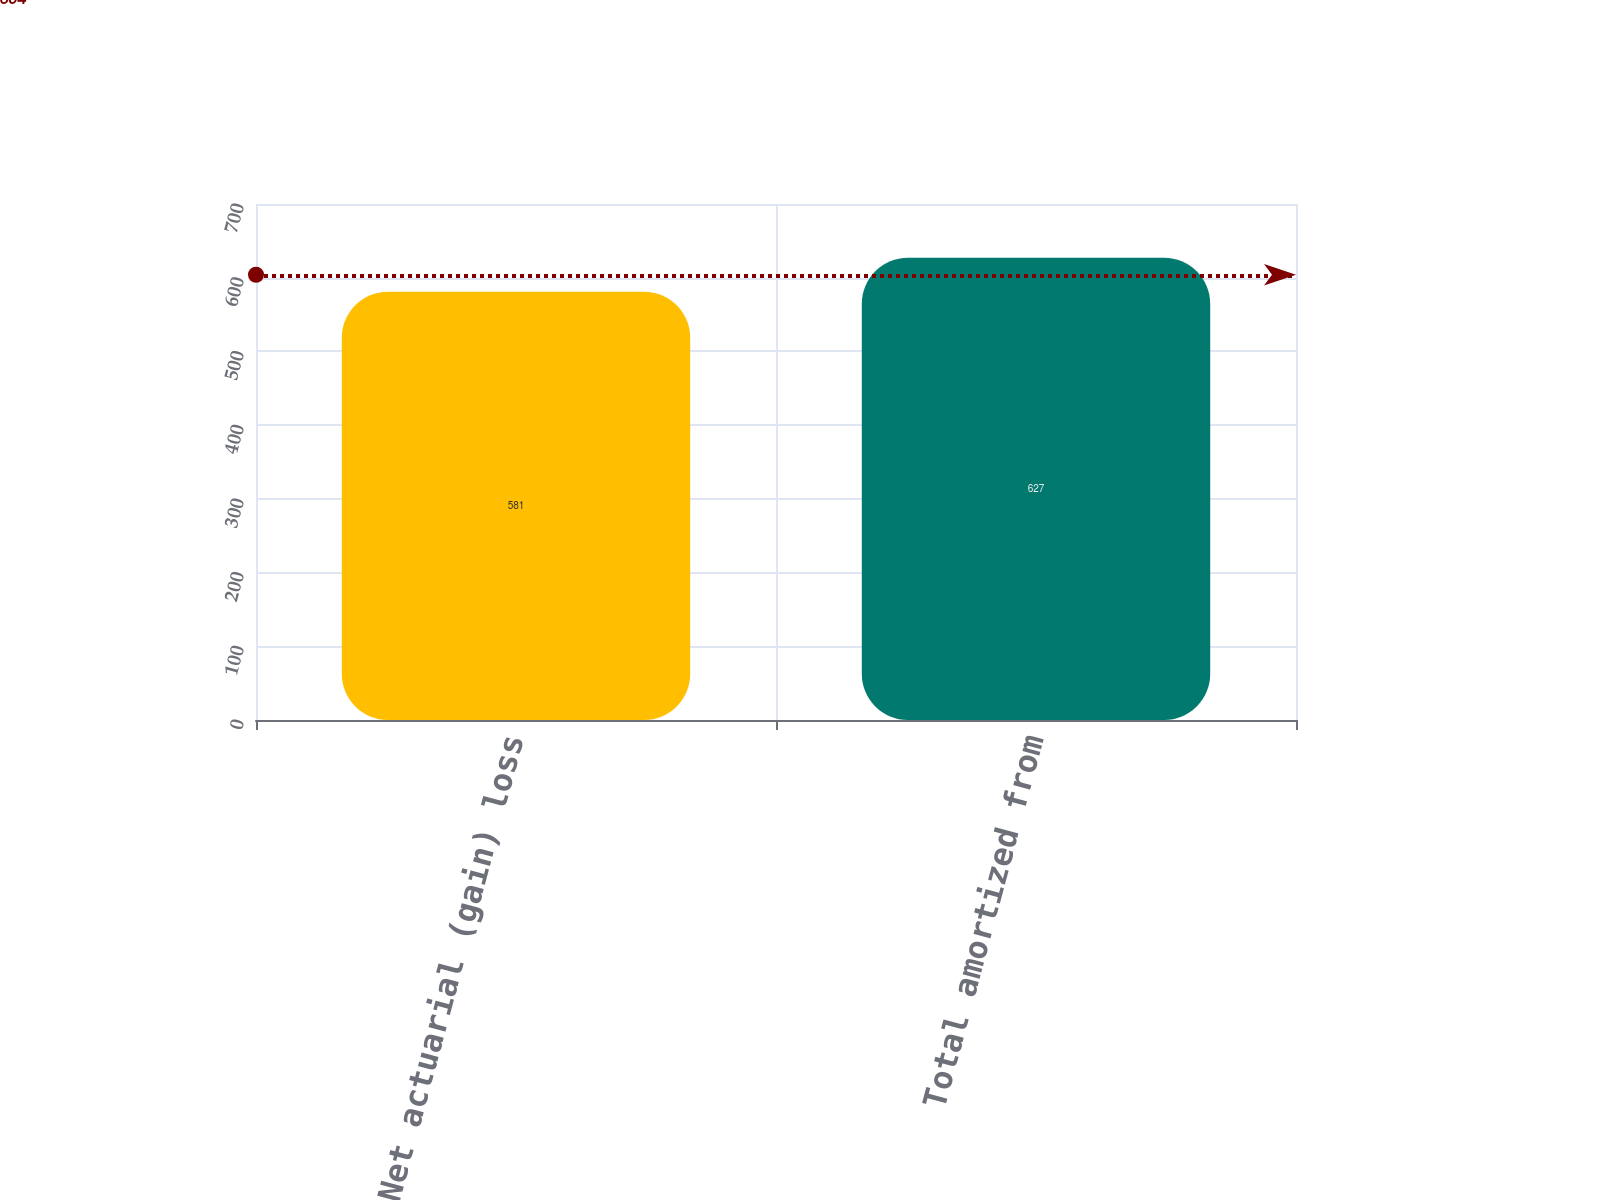Convert chart to OTSL. <chart><loc_0><loc_0><loc_500><loc_500><bar_chart><fcel>Net actuarial (gain) loss<fcel>Total amortized from<nl><fcel>581<fcel>627<nl></chart> 